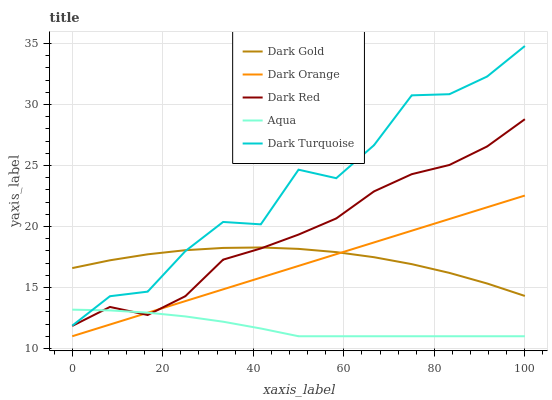Does Aqua have the minimum area under the curve?
Answer yes or no. Yes. Does Dark Turquoise have the maximum area under the curve?
Answer yes or no. Yes. Does Dark Red have the minimum area under the curve?
Answer yes or no. No. Does Dark Red have the maximum area under the curve?
Answer yes or no. No. Is Dark Orange the smoothest?
Answer yes or no. Yes. Is Dark Turquoise the roughest?
Answer yes or no. Yes. Is Dark Red the smoothest?
Answer yes or no. No. Is Dark Red the roughest?
Answer yes or no. No. Does Dark Orange have the lowest value?
Answer yes or no. Yes. Does Dark Red have the lowest value?
Answer yes or no. No. Does Dark Turquoise have the highest value?
Answer yes or no. Yes. Does Dark Red have the highest value?
Answer yes or no. No. Is Dark Red less than Dark Turquoise?
Answer yes or no. Yes. Is Dark Turquoise greater than Dark Orange?
Answer yes or no. Yes. Does Dark Orange intersect Dark Red?
Answer yes or no. Yes. Is Dark Orange less than Dark Red?
Answer yes or no. No. Is Dark Orange greater than Dark Red?
Answer yes or no. No. Does Dark Red intersect Dark Turquoise?
Answer yes or no. No. 